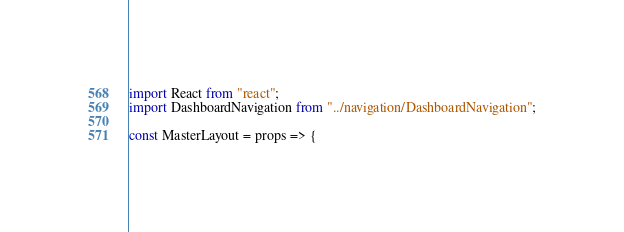<code> <loc_0><loc_0><loc_500><loc_500><_JavaScript_>import React from "react";
import DashboardNavigation from "../navigation/DashboardNavigation";

const MasterLayout = props => {</code> 